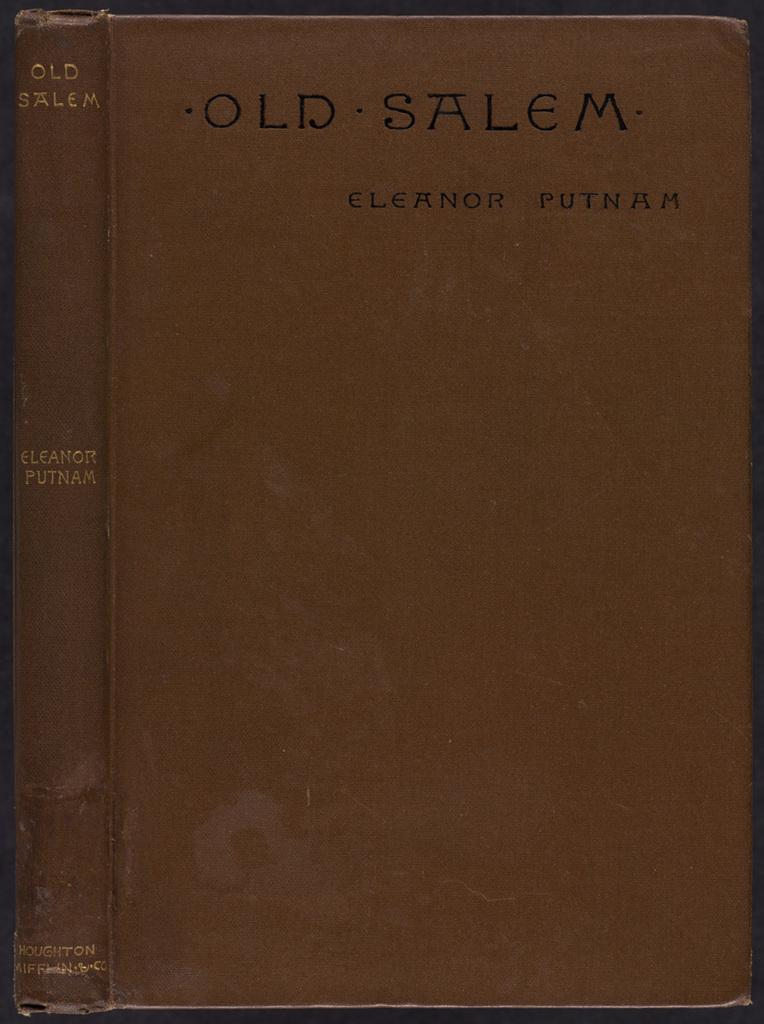Provide a one-sentence caption for the provided image. Front of an old red hardback book Old Salem by Eleanor Putman. 